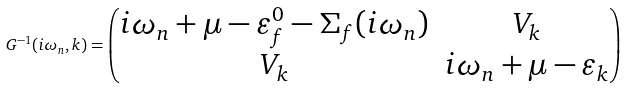Convert formula to latex. <formula><loc_0><loc_0><loc_500><loc_500>G ^ { - 1 } ( i \omega _ { n } , k ) = \begin{pmatrix} i \omega _ { n } + \mu - \varepsilon _ { f } ^ { 0 } - \Sigma _ { f } ( i \omega _ { n } ) & V _ { k } \\ V _ { k } & i \omega _ { n } + \mu - \varepsilon _ { k } \end{pmatrix}</formula> 